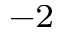Convert formula to latex. <formula><loc_0><loc_0><loc_500><loc_500>^ { - 2 }</formula> 